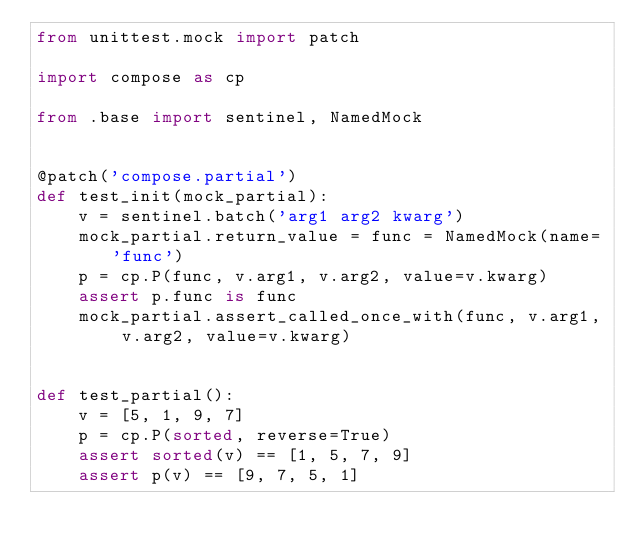<code> <loc_0><loc_0><loc_500><loc_500><_Python_>from unittest.mock import patch

import compose as cp

from .base import sentinel, NamedMock


@patch('compose.partial')
def test_init(mock_partial):
    v = sentinel.batch('arg1 arg2 kwarg')
    mock_partial.return_value = func = NamedMock(name='func')
    p = cp.P(func, v.arg1, v.arg2, value=v.kwarg)
    assert p.func is func
    mock_partial.assert_called_once_with(func, v.arg1, v.arg2, value=v.kwarg)


def test_partial():
    v = [5, 1, 9, 7]
    p = cp.P(sorted, reverse=True)
    assert sorted(v) == [1, 5, 7, 9]
    assert p(v) == [9, 7, 5, 1]
</code> 